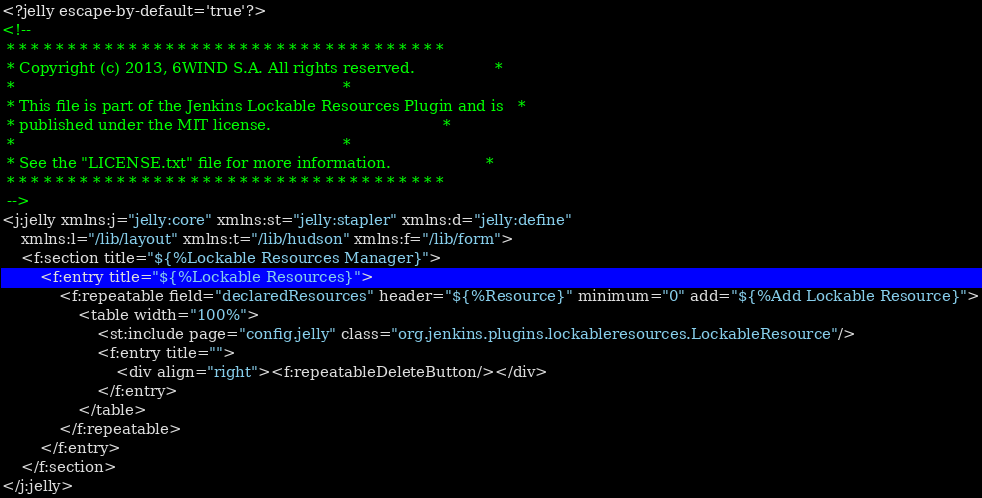Convert code to text. <code><loc_0><loc_0><loc_500><loc_500><_XML_><?jelly escape-by-default='true'?>
<!--
 * * * * * * * * * * * * * * * * * * * * * * * * * * * * * * * * * * * *
 * Copyright (c) 2013, 6WIND S.A. All rights reserved.                 *
 *                                                                     *
 * This file is part of the Jenkins Lockable Resources Plugin and is   *
 * published under the MIT license.                                    *
 *                                                                     *
 * See the "LICENSE.txt" file for more information.                    *
 * * * * * * * * * * * * * * * * * * * * * * * * * * * * * * * * * * * *
 -->
<j:jelly xmlns:j="jelly:core" xmlns:st="jelly:stapler" xmlns:d="jelly:define"
	xmlns:l="/lib/layout" xmlns:t="/lib/hudson" xmlns:f="/lib/form">
	<f:section title="${%Lockable Resources Manager}">
		<f:entry title="${%Lockable Resources}">
			<f:repeatable field="declaredResources" header="${%Resource}" minimum="0" add="${%Add Lockable Resource}">
				<table width="100%">
					<st:include page="config.jelly" class="org.jenkins.plugins.lockableresources.LockableResource"/>
					<f:entry title="">
						<div align="right"><f:repeatableDeleteButton/></div>
					</f:entry>
				</table>
			</f:repeatable>
		</f:entry>
	</f:section>
</j:jelly>
</code> 